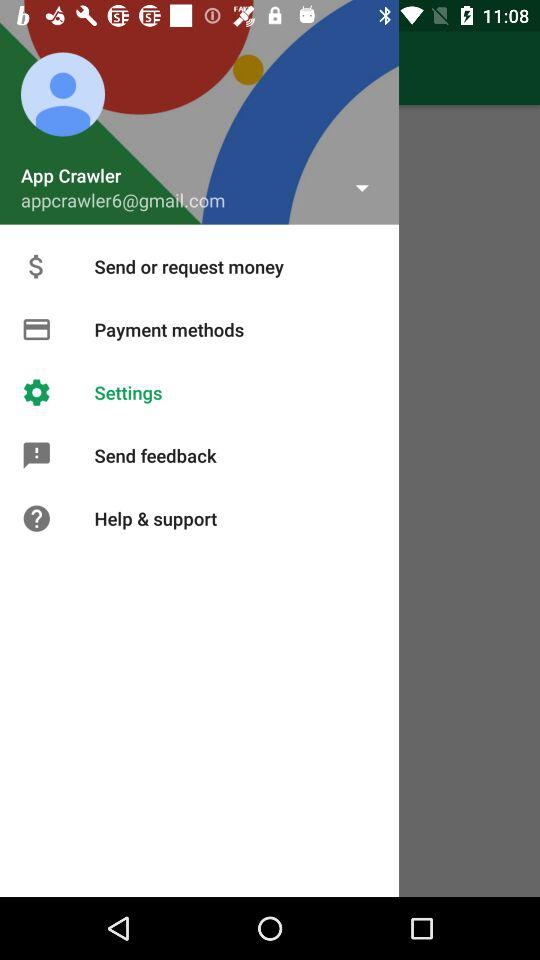Which option is selected? The selected option is "Settings". 